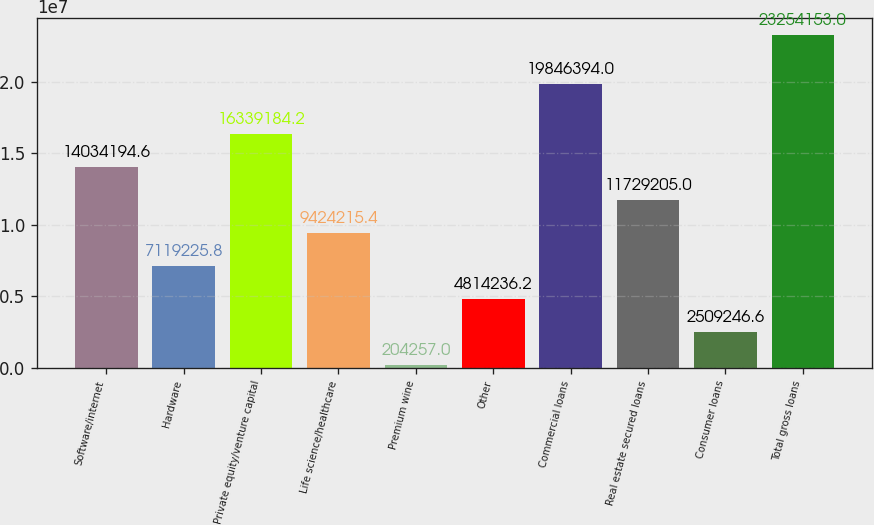Convert chart to OTSL. <chart><loc_0><loc_0><loc_500><loc_500><bar_chart><fcel>Software/internet<fcel>Hardware<fcel>Private equity/venture capital<fcel>Life science/healthcare<fcel>Premium wine<fcel>Other<fcel>Commercial loans<fcel>Real estate secured loans<fcel>Consumer loans<fcel>Total gross loans<nl><fcel>1.40342e+07<fcel>7.11923e+06<fcel>1.63392e+07<fcel>9.42422e+06<fcel>204257<fcel>4.81424e+06<fcel>1.98464e+07<fcel>1.17292e+07<fcel>2.50925e+06<fcel>2.32542e+07<nl></chart> 